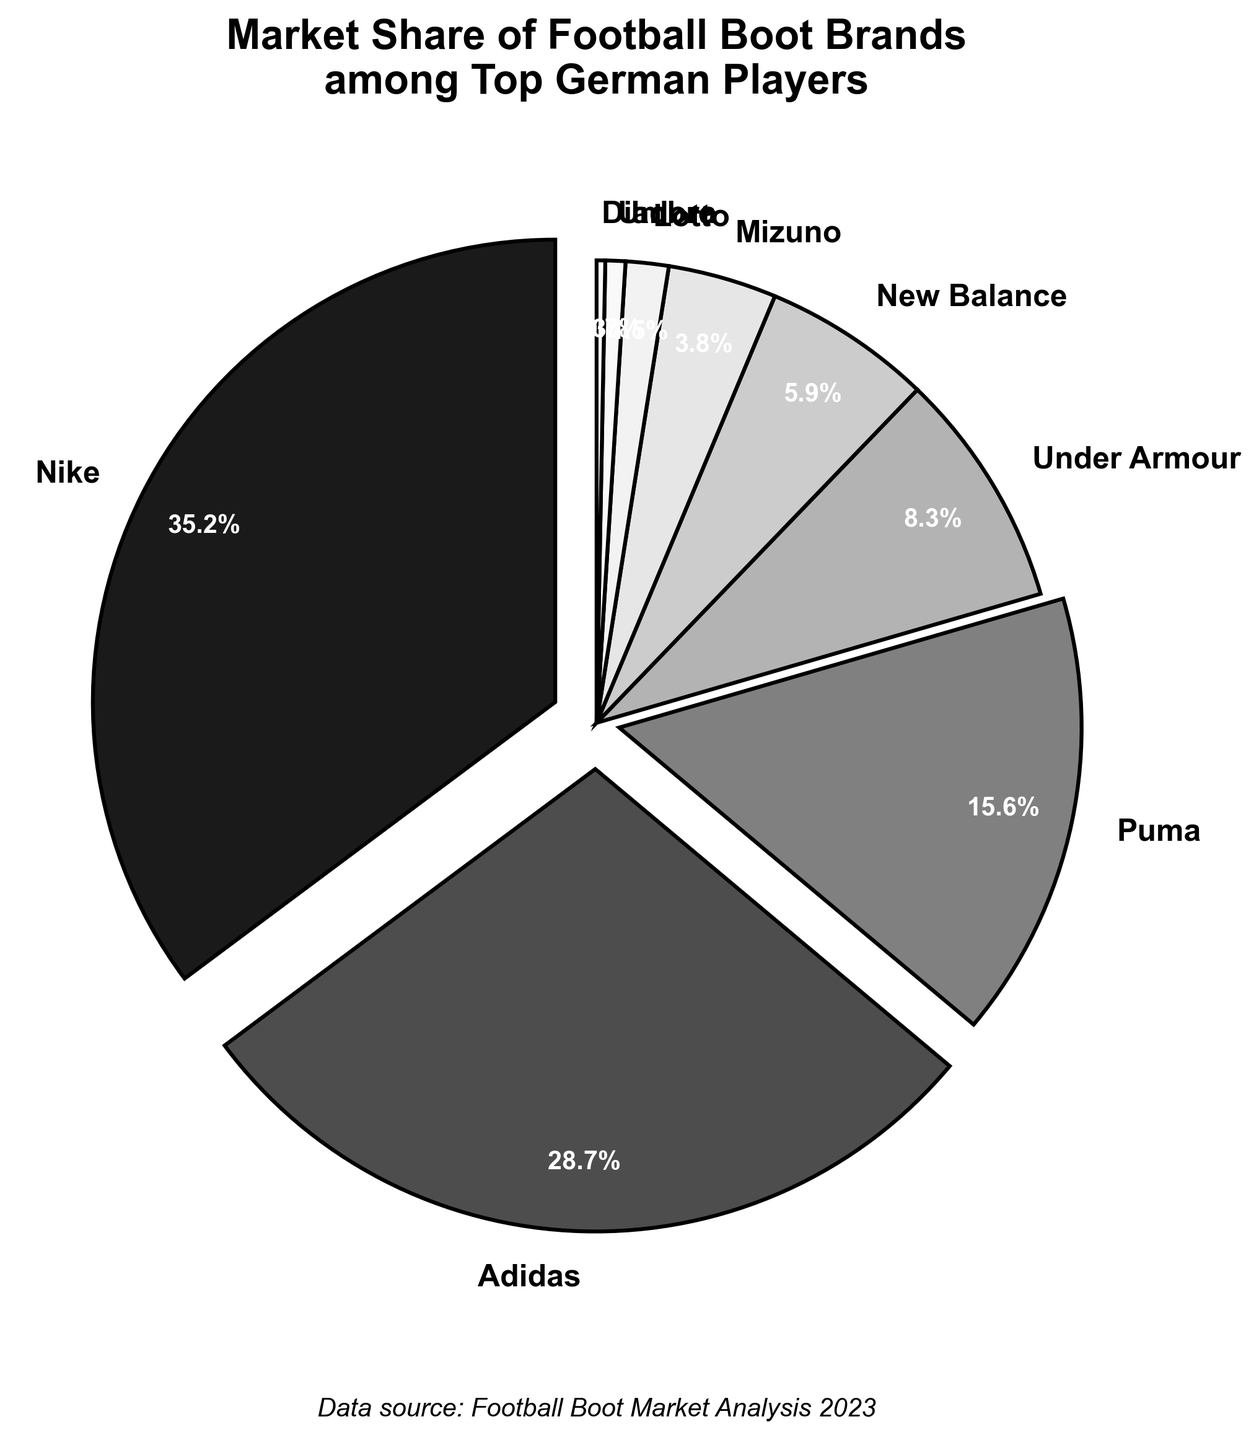What's the most popular boot brand among top German players? The pie chart shows the market share percentages for each brand. The brand with the largest segment represents the most popular boot brand.
Answer: Nike Which brand has a market share of 28.7%? By observing the labels on the pie chart, we can identify that the segment with a 28.7% market share corresponds to Adidas.
Answer: Adidas How much larger is Nike's market share compared to Adidas? Nike has a market share of 35.2% and Adidas has 28.7%. Subtracting the two: 35.2% - 28.7% = 6.5%.
Answer: 6.5% Which brands have a market share below 5%? Observing the pie chart, we can see the following brands with market shares below 5%: New Balance (5.9%), Mizuno (3.8%), Lotto (1.5%), Umbro (0.7%), and Diadora (0.3%).
Answer: Mizuno, Lotto, Umbro, Diadora Do Under Armour and Puma together have a higher market share than Adidas? Under Armour has a market share of 8.3% and Puma has 15.6%. Adding these together: 8.3% + 15.6% = 23.9%. Since 23.9% is less than Adidas's 28.7%, they do not have a higher combined market share than Adidas.
Answer: No What's the combined market share of the brands with less than 10% each? The brands with less than 10% are Under Armour (8.3%), New Balance (5.9%), Mizuno (3.8%), Lotto (1.5%), Umbro (0.7%), and Diadora (0.3%). Adding these: 8.3% + 5.9% + 3.8% + 1.5% + 0.7% + 0.3% = 20.5%.
Answer: 20.5% What are the colors used to represent Nike and Adidas in the chart? The pie chart uses a grayscale color palette. Nike is represented by the darkest color (#1a1a1a) and Adidas is the second darkest color (#4d4d4d).
Answer: Dark gray for Nike, slightly lighter dark gray for Adidas What is the market share difference between the least popular and most popular brands? The most popular brand, Nike, has a market share of 35.2%, and the least popular brand, Diadora, has 0.3%. The difference is 35.2% - 0.3% = 34.9%.
Answer: 34.9% Which brand is represented by the lightest shade in the pie chart? The lightest shade of gray (#ffffff) in the pie chart represents Diadora, which has the smallest market share of 0.3%.
Answer: Diadora Of the top three brands, which has the smallest market share? The top three brands by market share are Nike (35.2%), Adidas (28.7%), and Puma (15.6%). The smallest among these is Puma.
Answer: Puma 